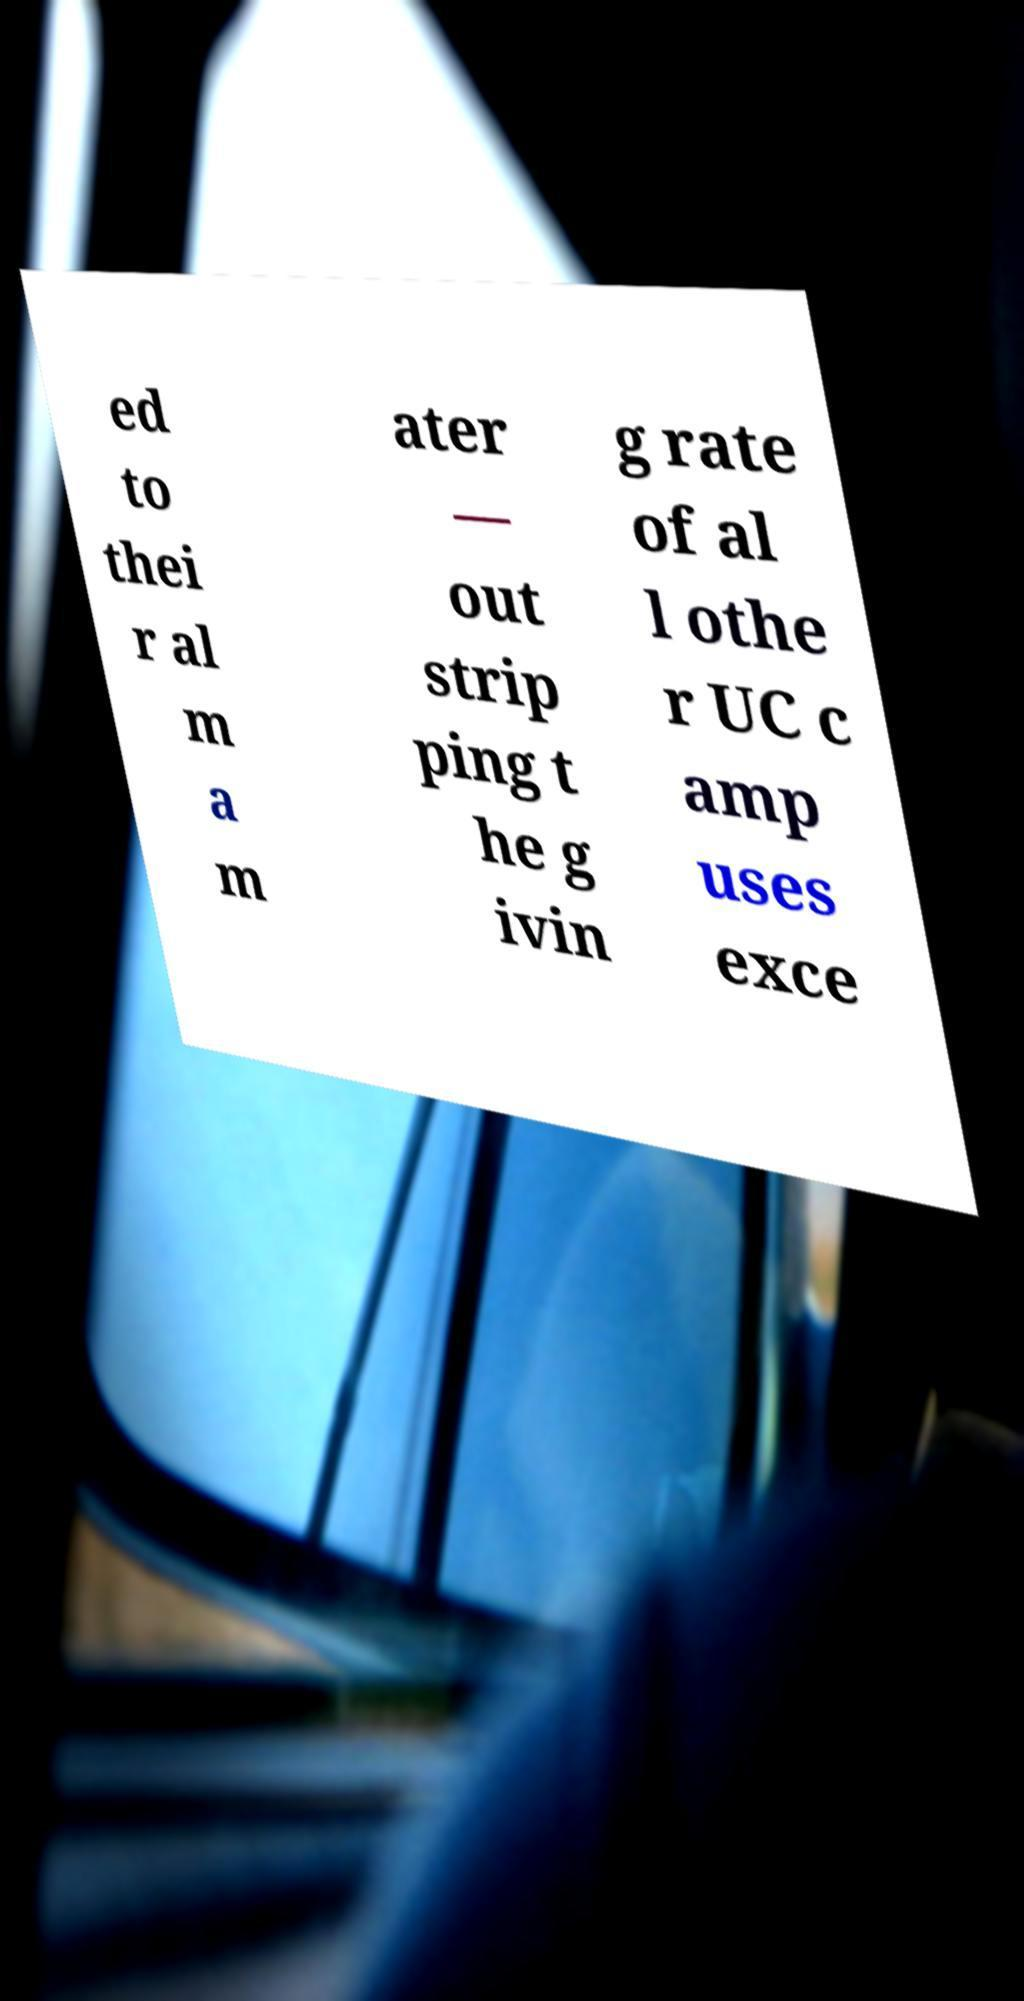Could you assist in decoding the text presented in this image and type it out clearly? ed to thei r al m a m ater — out strip ping t he g ivin g rate of al l othe r UC c amp uses exce 